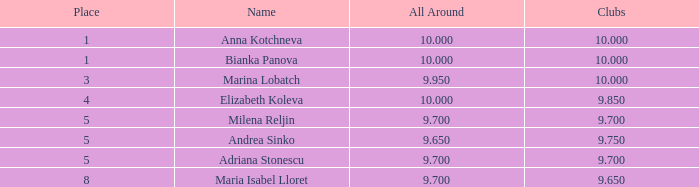What is the highest total that has andrea sinko as the name, with an all around greater than 9.65? None. I'm looking to parse the entire table for insights. Could you assist me with that? {'header': ['Place', 'Name', 'All Around', 'Clubs'], 'rows': [['1', 'Anna Kotchneva', '10.000', '10.000'], ['1', 'Bianka Panova', '10.000', '10.000'], ['3', 'Marina Lobatch', '9.950', '10.000'], ['4', 'Elizabeth Koleva', '10.000', '9.850'], ['5', 'Milena Reljin', '9.700', '9.700'], ['5', 'Andrea Sinko', '9.650', '9.750'], ['5', 'Adriana Stonescu', '9.700', '9.700'], ['8', 'Maria Isabel Lloret', '9.700', '9.650']]} 